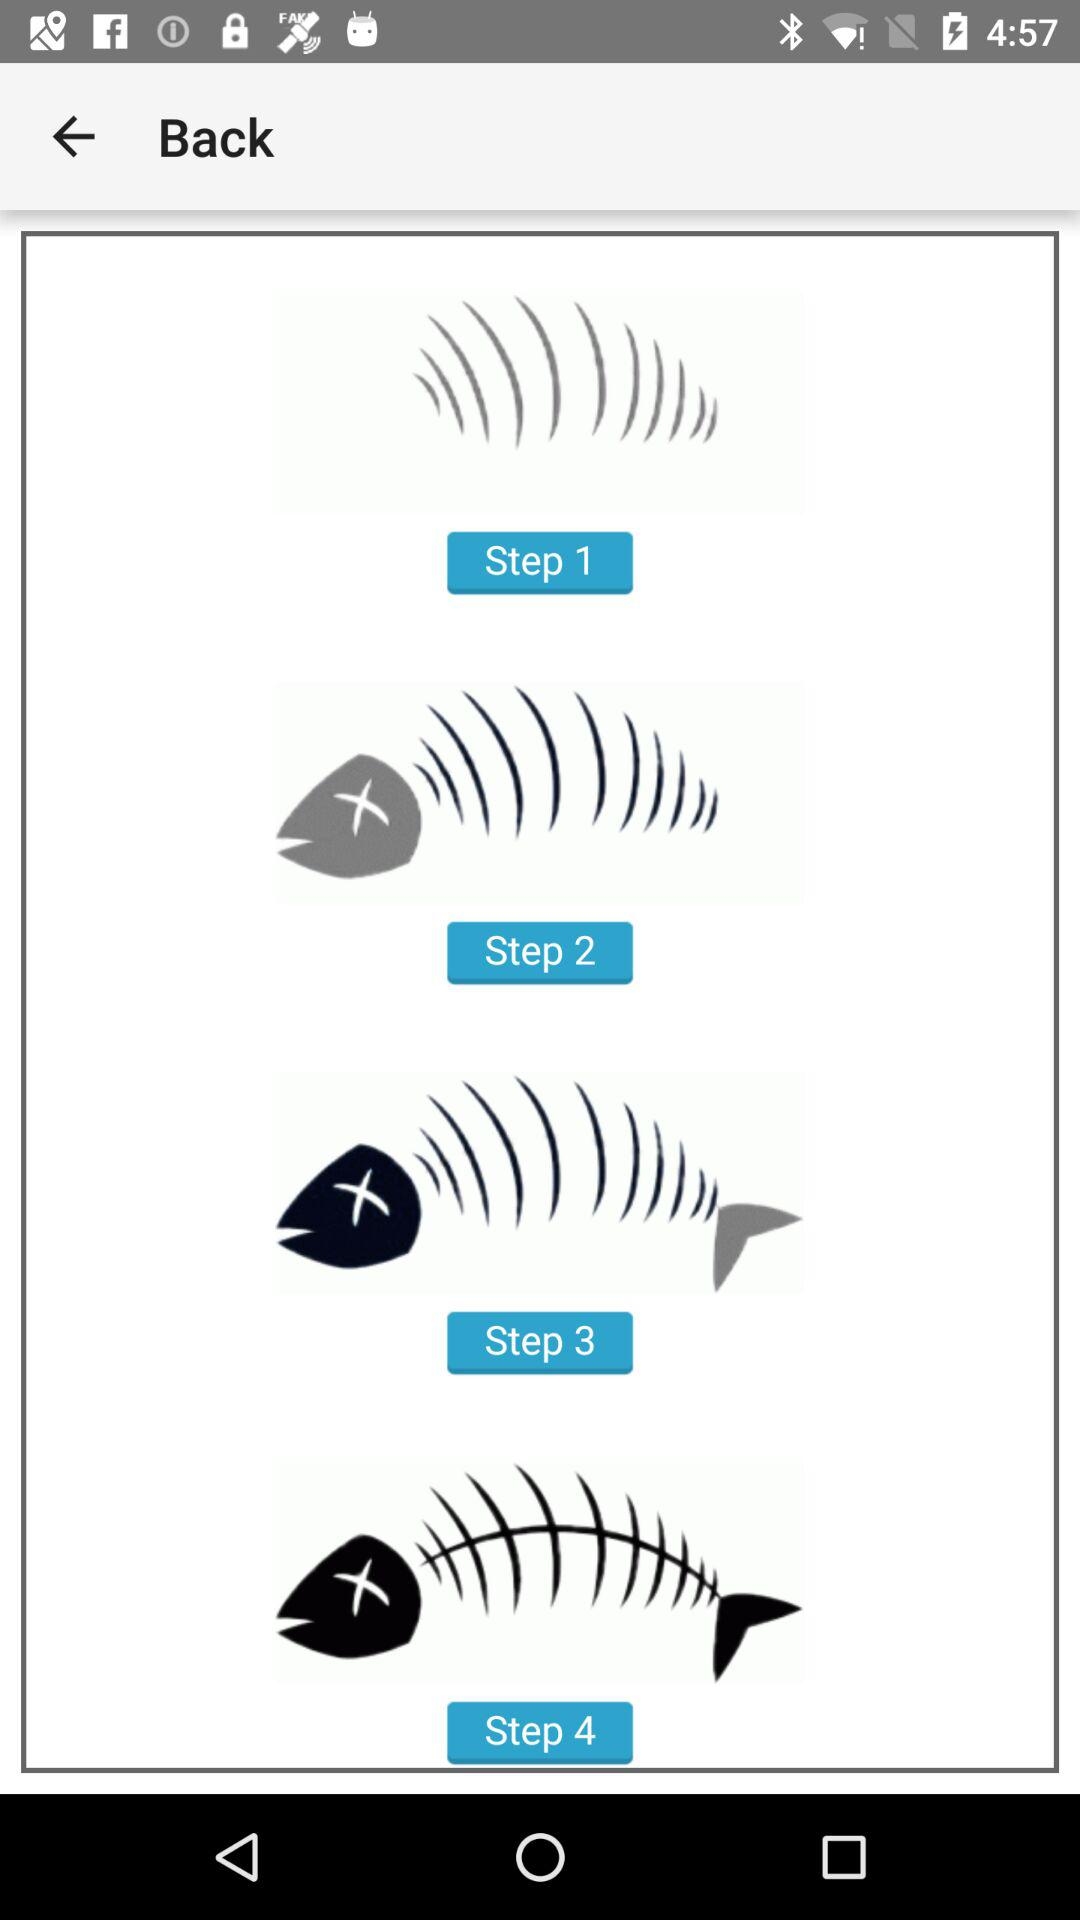How many steps are there in the tutorial?
Answer the question using a single word or phrase. 4 